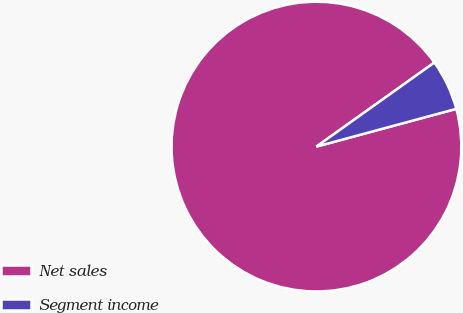Convert chart to OTSL. <chart><loc_0><loc_0><loc_500><loc_500><pie_chart><fcel>Net sales<fcel>Segment income<nl><fcel>94.34%<fcel>5.66%<nl></chart> 